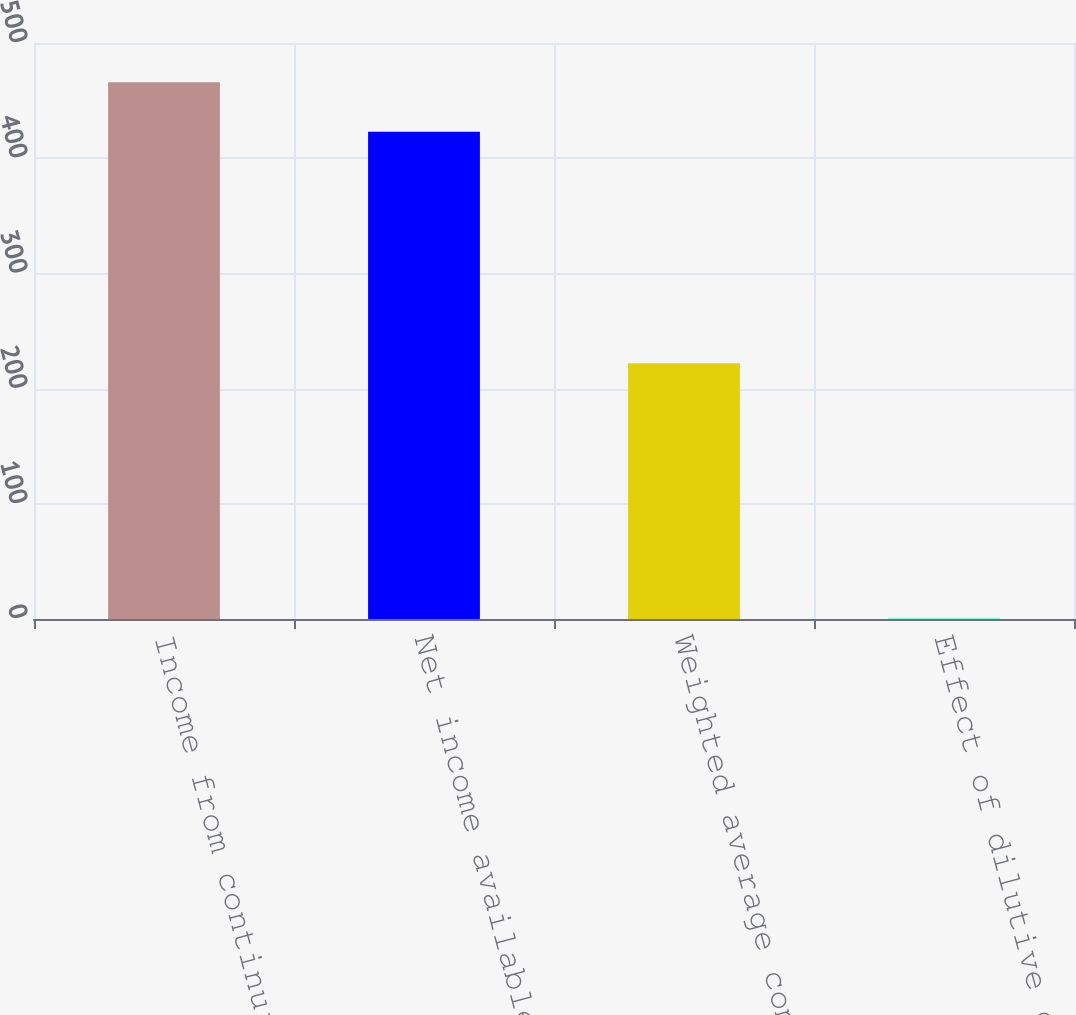<chart> <loc_0><loc_0><loc_500><loc_500><bar_chart><fcel>Income from continuing<fcel>Net income available to common<fcel>Weighted average common shares<fcel>Effect of dilutive common<nl><fcel>465.9<fcel>423<fcel>221.9<fcel>1<nl></chart> 